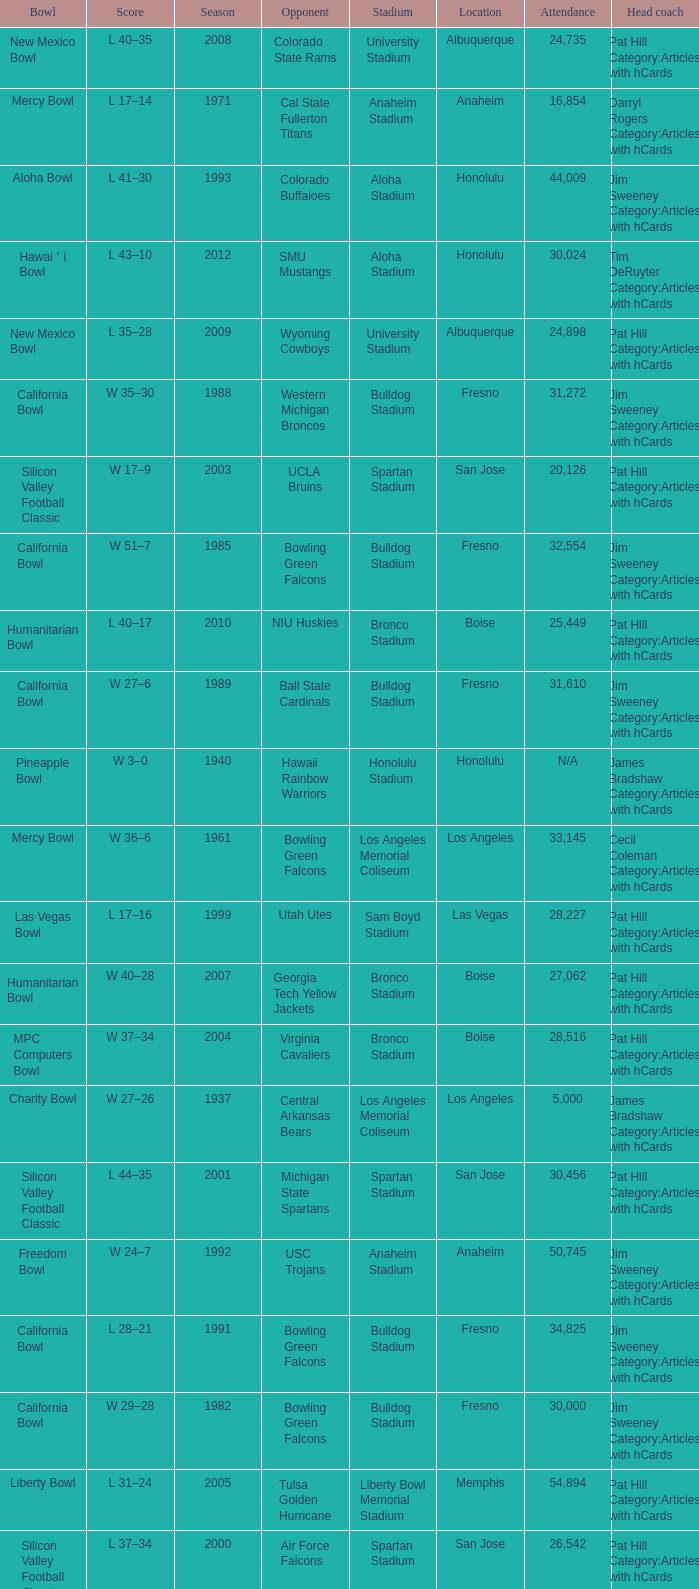Where was the California bowl played with 30,000 attending? Fresno. 